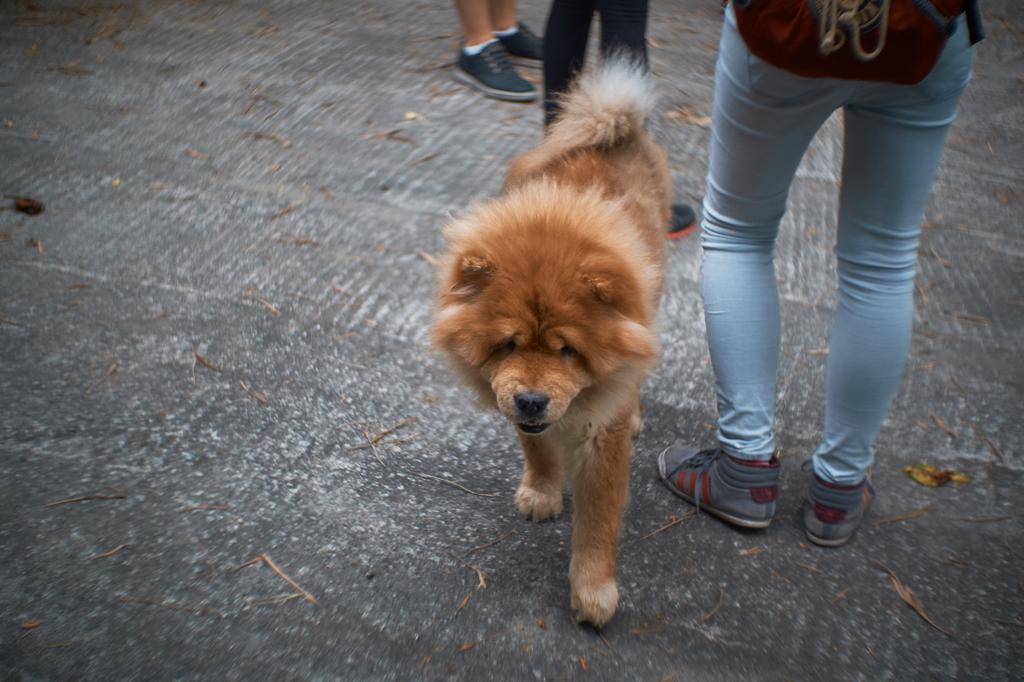What type of animal is in the image? There is a brown dog in the image. Are there any people near the dog? Yes, there are people near the dog. Can you describe the person on the right side of the image? One person on the right side of the image is wearing a bag. What sound do the bells make when the dog turns its head? There are no bells present in the image, and the dog is not turning its head. 